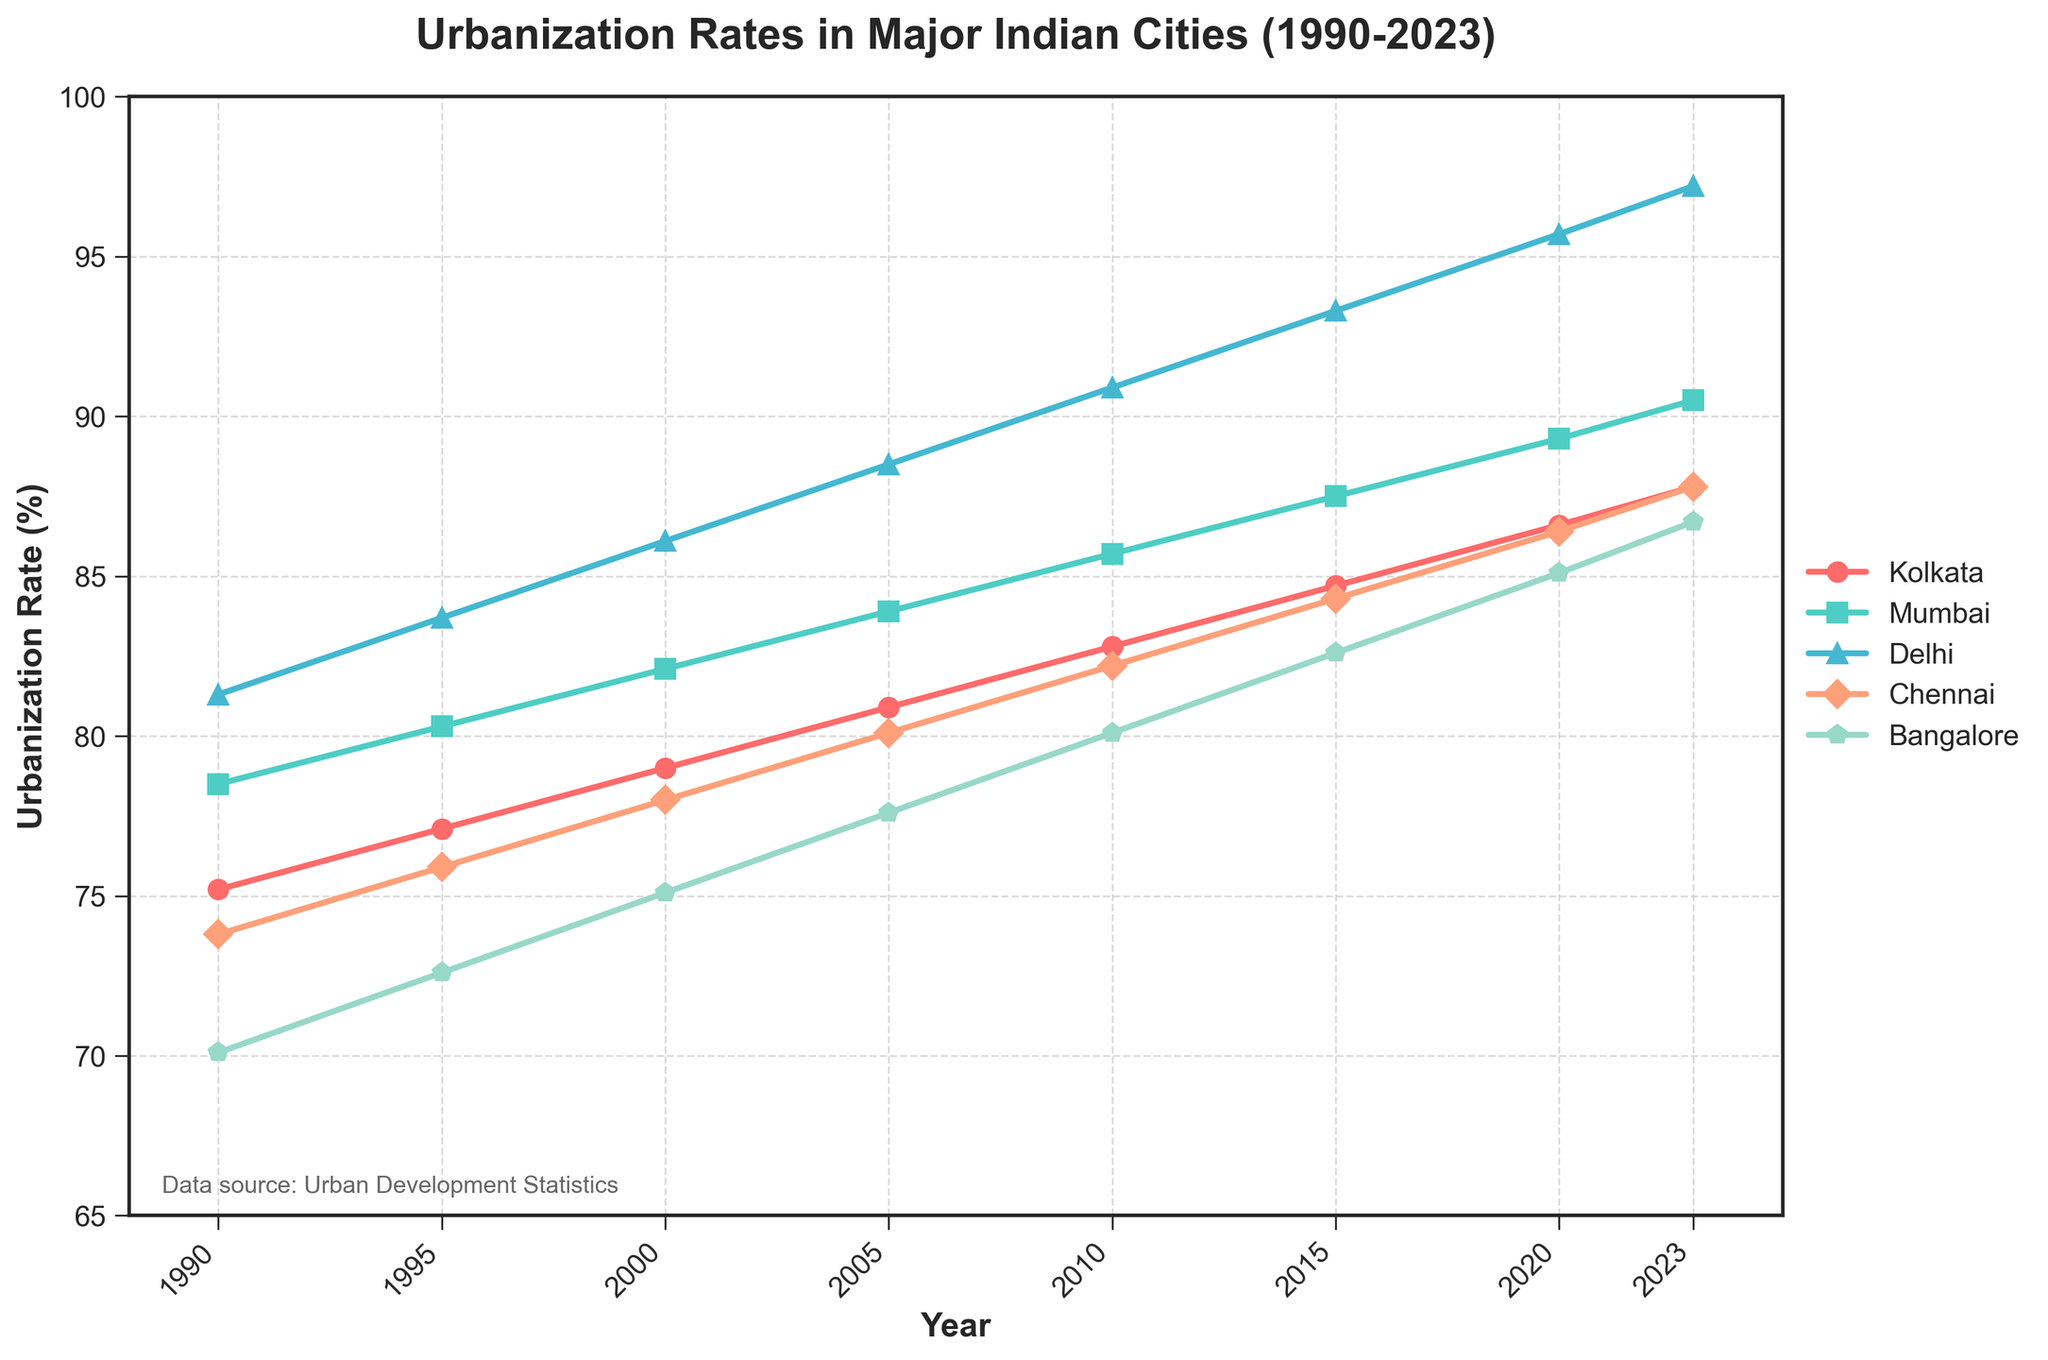What is the difference in urbanization rates between Delhi and Kolkata in 2023? In 2023, Delhi’s urbanization rate is 97.2% and Kolkata’s is 87.8%. The difference is 97.2 - 87.8 = 9.4%
Answer: 9.4% Which city had the highest rate of urbanization in 1990? In 1990, comparing the urbanization rates, Delhi had the highest rate at 81.3%
Answer: Delhi What is the average urbanization rate for Kolkata from 1990 to 2023? The rates for Kolkata are 75.2%, 77.1%, 79.0%, 80.9%, 82.8%, 84.7%, 86.6%, and 87.8%. Summing them up gives 674.1%. Dividing by the number of years (8), the average rate is 674.1 / 8 ≈ 84.3%
Answer: 84.3% What city had the smallest urbanization rate in 2010? In 2010, comparing all cities, Bangalore had the smallest rate at 80.1%
Answer: Bangalore Which city shows the most consistent upward trend without any drops? All cities show an upward trend without drops, but examining the rates, no city has any decrease in the rates provided in the data
Answer: All cities What is the combined urbanization rate for Kolkata and Chennai in 2005? In 2005, Kolkata’s rate is 80.9% and Chennai’s is 80.1%. The combined rate is 80.9 + 80.1 = 161%
Answer: 161% By how much did Bangalore’s urbanization rate grow from 1990 to 2023? Bangalore’s rate in 1990 was 70.1% and in 2023 it is 86.7%. The growth is 86.7 - 70.1 = 16.6%
Answer: 16.6% Which city had the least urbanization rate in 1995 and what was the rate? In 1995, comparing the rates, Bangalore had the least rate at 72.6%
Answer: Bangalore, 72.6% 